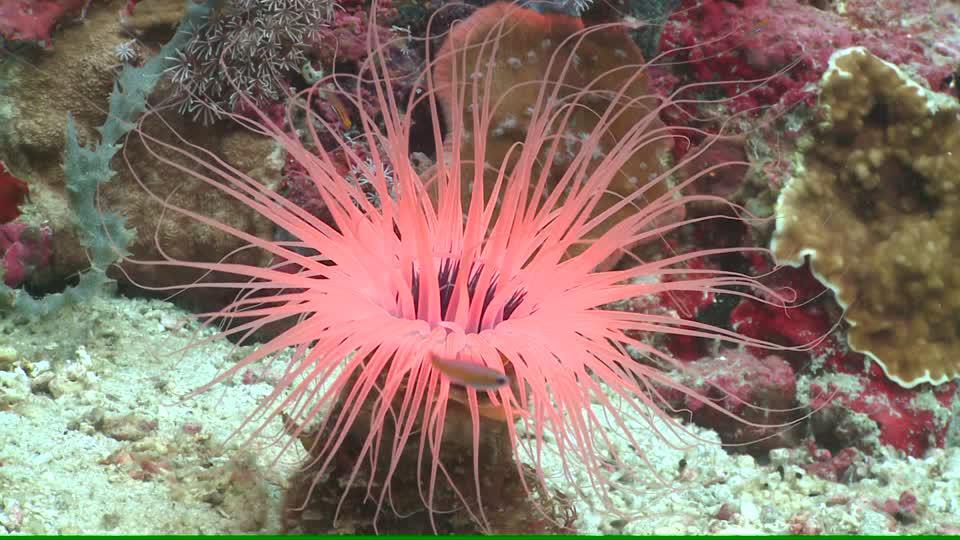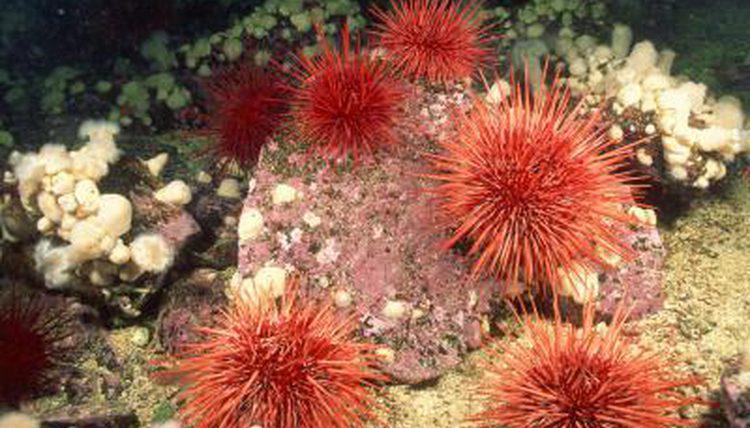The first image is the image on the left, the second image is the image on the right. For the images shown, is this caption "An image shows multipe individual orange anemone and no other color anemone." true? Answer yes or no. Yes. The first image is the image on the left, the second image is the image on the right. Assess this claim about the two images: "there are at least six red anemones in one of the images". Correct or not? Answer yes or no. Yes. 